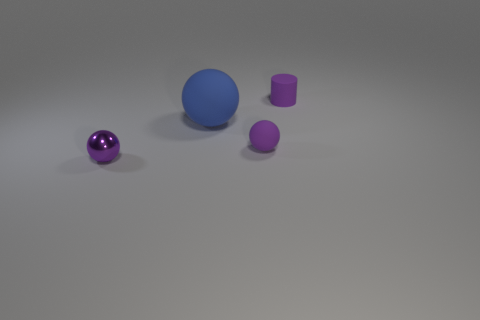Add 4 purple cylinders. How many objects exist? 8 Subtract all purple spheres. How many spheres are left? 1 Subtract all purple balls. How many balls are left? 1 Subtract 1 cylinders. How many cylinders are left? 0 Subtract 1 purple cylinders. How many objects are left? 3 Subtract all spheres. How many objects are left? 1 Subtract all blue spheres. Subtract all purple cubes. How many spheres are left? 2 Subtract all cyan balls. How many gray cylinders are left? 0 Subtract all small objects. Subtract all purple shiny spheres. How many objects are left? 0 Add 4 small purple rubber spheres. How many small purple rubber spheres are left? 5 